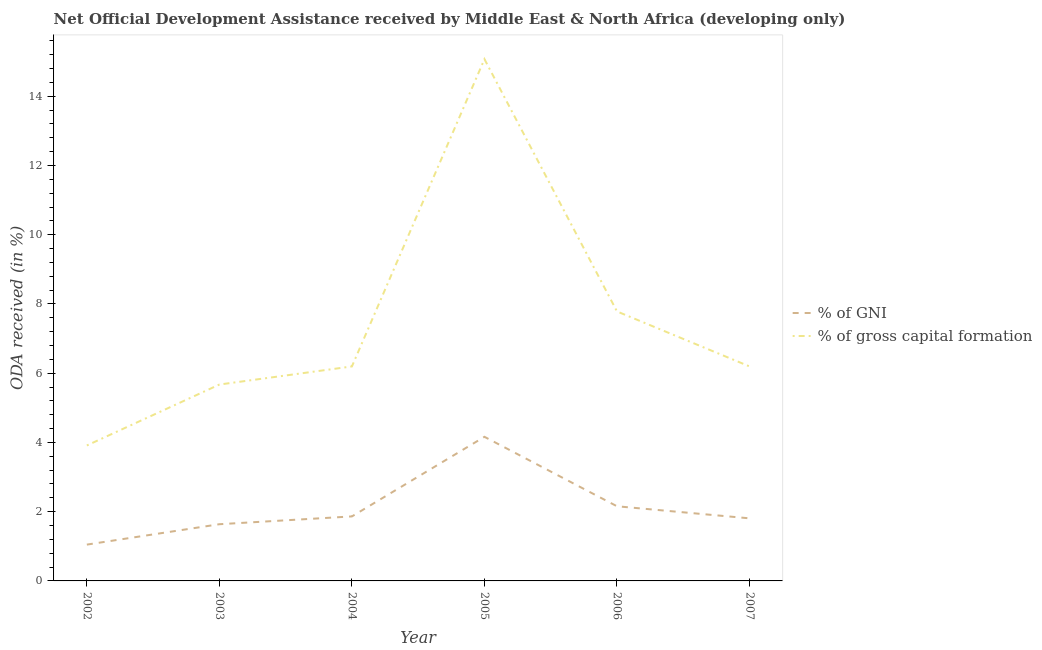Does the line corresponding to oda received as percentage of gni intersect with the line corresponding to oda received as percentage of gross capital formation?
Make the answer very short. No. What is the oda received as percentage of gross capital formation in 2005?
Provide a short and direct response. 15.07. Across all years, what is the maximum oda received as percentage of gni?
Ensure brevity in your answer.  4.16. Across all years, what is the minimum oda received as percentage of gni?
Offer a very short reply. 1.05. In which year was the oda received as percentage of gross capital formation maximum?
Your response must be concise. 2005. In which year was the oda received as percentage of gni minimum?
Your answer should be compact. 2002. What is the total oda received as percentage of gross capital formation in the graph?
Keep it short and to the point. 44.83. What is the difference between the oda received as percentage of gni in 2002 and that in 2003?
Your response must be concise. -0.59. What is the difference between the oda received as percentage of gni in 2006 and the oda received as percentage of gross capital formation in 2007?
Offer a very short reply. -4.04. What is the average oda received as percentage of gni per year?
Provide a short and direct response. 2.11. In the year 2005, what is the difference between the oda received as percentage of gni and oda received as percentage of gross capital formation?
Your response must be concise. -10.91. What is the ratio of the oda received as percentage of gni in 2002 to that in 2005?
Provide a succinct answer. 0.25. Is the oda received as percentage of gross capital formation in 2004 less than that in 2005?
Ensure brevity in your answer.  Yes. Is the difference between the oda received as percentage of gross capital formation in 2002 and 2003 greater than the difference between the oda received as percentage of gni in 2002 and 2003?
Make the answer very short. No. What is the difference between the highest and the second highest oda received as percentage of gross capital formation?
Your response must be concise. 7.29. What is the difference between the highest and the lowest oda received as percentage of gross capital formation?
Give a very brief answer. 11.16. Is the oda received as percentage of gross capital formation strictly greater than the oda received as percentage of gni over the years?
Provide a succinct answer. Yes. How many lines are there?
Provide a succinct answer. 2. How many years are there in the graph?
Give a very brief answer. 6. What is the difference between two consecutive major ticks on the Y-axis?
Your answer should be very brief. 2. Does the graph contain any zero values?
Keep it short and to the point. No. Where does the legend appear in the graph?
Offer a very short reply. Center right. How many legend labels are there?
Make the answer very short. 2. How are the legend labels stacked?
Provide a succinct answer. Vertical. What is the title of the graph?
Keep it short and to the point. Net Official Development Assistance received by Middle East & North Africa (developing only). Does "current US$" appear as one of the legend labels in the graph?
Give a very brief answer. No. What is the label or title of the Y-axis?
Provide a succinct answer. ODA received (in %). What is the ODA received (in %) of % of GNI in 2002?
Offer a very short reply. 1.05. What is the ODA received (in %) in % of gross capital formation in 2002?
Your answer should be very brief. 3.91. What is the ODA received (in %) in % of GNI in 2003?
Offer a very short reply. 1.64. What is the ODA received (in %) of % of gross capital formation in 2003?
Keep it short and to the point. 5.67. What is the ODA received (in %) in % of GNI in 2004?
Provide a succinct answer. 1.86. What is the ODA received (in %) in % of gross capital formation in 2004?
Provide a short and direct response. 6.2. What is the ODA received (in %) of % of GNI in 2005?
Ensure brevity in your answer.  4.16. What is the ODA received (in %) of % of gross capital formation in 2005?
Your answer should be very brief. 15.07. What is the ODA received (in %) in % of GNI in 2006?
Give a very brief answer. 2.16. What is the ODA received (in %) of % of gross capital formation in 2006?
Your response must be concise. 7.78. What is the ODA received (in %) of % of GNI in 2007?
Provide a short and direct response. 1.81. What is the ODA received (in %) of % of gross capital formation in 2007?
Give a very brief answer. 6.2. Across all years, what is the maximum ODA received (in %) of % of GNI?
Offer a very short reply. 4.16. Across all years, what is the maximum ODA received (in %) of % of gross capital formation?
Your answer should be very brief. 15.07. Across all years, what is the minimum ODA received (in %) of % of GNI?
Provide a succinct answer. 1.05. Across all years, what is the minimum ODA received (in %) in % of gross capital formation?
Provide a succinct answer. 3.91. What is the total ODA received (in %) in % of GNI in the graph?
Provide a short and direct response. 12.68. What is the total ODA received (in %) in % of gross capital formation in the graph?
Offer a terse response. 44.83. What is the difference between the ODA received (in %) in % of GNI in 2002 and that in 2003?
Make the answer very short. -0.59. What is the difference between the ODA received (in %) of % of gross capital formation in 2002 and that in 2003?
Provide a succinct answer. -1.76. What is the difference between the ODA received (in %) in % of GNI in 2002 and that in 2004?
Keep it short and to the point. -0.81. What is the difference between the ODA received (in %) in % of gross capital formation in 2002 and that in 2004?
Make the answer very short. -2.28. What is the difference between the ODA received (in %) of % of GNI in 2002 and that in 2005?
Your answer should be very brief. -3.11. What is the difference between the ODA received (in %) of % of gross capital formation in 2002 and that in 2005?
Make the answer very short. -11.16. What is the difference between the ODA received (in %) in % of GNI in 2002 and that in 2006?
Provide a short and direct response. -1.11. What is the difference between the ODA received (in %) in % of gross capital formation in 2002 and that in 2006?
Provide a short and direct response. -3.87. What is the difference between the ODA received (in %) of % of GNI in 2002 and that in 2007?
Your answer should be very brief. -0.76. What is the difference between the ODA received (in %) in % of gross capital formation in 2002 and that in 2007?
Provide a succinct answer. -2.28. What is the difference between the ODA received (in %) in % of GNI in 2003 and that in 2004?
Provide a short and direct response. -0.23. What is the difference between the ODA received (in %) in % of gross capital formation in 2003 and that in 2004?
Give a very brief answer. -0.52. What is the difference between the ODA received (in %) in % of GNI in 2003 and that in 2005?
Give a very brief answer. -2.52. What is the difference between the ODA received (in %) of % of gross capital formation in 2003 and that in 2005?
Offer a very short reply. -9.4. What is the difference between the ODA received (in %) in % of GNI in 2003 and that in 2006?
Provide a short and direct response. -0.52. What is the difference between the ODA received (in %) of % of gross capital formation in 2003 and that in 2006?
Your answer should be very brief. -2.11. What is the difference between the ODA received (in %) of % of GNI in 2003 and that in 2007?
Offer a terse response. -0.17. What is the difference between the ODA received (in %) in % of gross capital formation in 2003 and that in 2007?
Your answer should be very brief. -0.52. What is the difference between the ODA received (in %) of % of GNI in 2004 and that in 2005?
Your answer should be very brief. -2.3. What is the difference between the ODA received (in %) in % of gross capital formation in 2004 and that in 2005?
Your answer should be compact. -8.88. What is the difference between the ODA received (in %) of % of GNI in 2004 and that in 2006?
Make the answer very short. -0.29. What is the difference between the ODA received (in %) of % of gross capital formation in 2004 and that in 2006?
Offer a very short reply. -1.59. What is the difference between the ODA received (in %) in % of GNI in 2004 and that in 2007?
Your answer should be compact. 0.06. What is the difference between the ODA received (in %) of % of gross capital formation in 2004 and that in 2007?
Your response must be concise. -0. What is the difference between the ODA received (in %) in % of GNI in 2005 and that in 2006?
Provide a short and direct response. 2.01. What is the difference between the ODA received (in %) of % of gross capital formation in 2005 and that in 2006?
Keep it short and to the point. 7.29. What is the difference between the ODA received (in %) in % of GNI in 2005 and that in 2007?
Offer a very short reply. 2.35. What is the difference between the ODA received (in %) of % of gross capital formation in 2005 and that in 2007?
Your response must be concise. 8.88. What is the difference between the ODA received (in %) in % of GNI in 2006 and that in 2007?
Your response must be concise. 0.35. What is the difference between the ODA received (in %) in % of gross capital formation in 2006 and that in 2007?
Ensure brevity in your answer.  1.59. What is the difference between the ODA received (in %) of % of GNI in 2002 and the ODA received (in %) of % of gross capital formation in 2003?
Provide a short and direct response. -4.62. What is the difference between the ODA received (in %) in % of GNI in 2002 and the ODA received (in %) in % of gross capital formation in 2004?
Keep it short and to the point. -5.15. What is the difference between the ODA received (in %) of % of GNI in 2002 and the ODA received (in %) of % of gross capital formation in 2005?
Provide a succinct answer. -14.02. What is the difference between the ODA received (in %) of % of GNI in 2002 and the ODA received (in %) of % of gross capital formation in 2006?
Keep it short and to the point. -6.74. What is the difference between the ODA received (in %) of % of GNI in 2002 and the ODA received (in %) of % of gross capital formation in 2007?
Keep it short and to the point. -5.15. What is the difference between the ODA received (in %) of % of GNI in 2003 and the ODA received (in %) of % of gross capital formation in 2004?
Offer a terse response. -4.56. What is the difference between the ODA received (in %) in % of GNI in 2003 and the ODA received (in %) in % of gross capital formation in 2005?
Make the answer very short. -13.43. What is the difference between the ODA received (in %) in % of GNI in 2003 and the ODA received (in %) in % of gross capital formation in 2006?
Keep it short and to the point. -6.15. What is the difference between the ODA received (in %) in % of GNI in 2003 and the ODA received (in %) in % of gross capital formation in 2007?
Your answer should be very brief. -4.56. What is the difference between the ODA received (in %) of % of GNI in 2004 and the ODA received (in %) of % of gross capital formation in 2005?
Your answer should be very brief. -13.21. What is the difference between the ODA received (in %) of % of GNI in 2004 and the ODA received (in %) of % of gross capital formation in 2006?
Offer a very short reply. -5.92. What is the difference between the ODA received (in %) of % of GNI in 2004 and the ODA received (in %) of % of gross capital formation in 2007?
Your response must be concise. -4.33. What is the difference between the ODA received (in %) of % of GNI in 2005 and the ODA received (in %) of % of gross capital formation in 2006?
Ensure brevity in your answer.  -3.62. What is the difference between the ODA received (in %) in % of GNI in 2005 and the ODA received (in %) in % of gross capital formation in 2007?
Keep it short and to the point. -2.03. What is the difference between the ODA received (in %) of % of GNI in 2006 and the ODA received (in %) of % of gross capital formation in 2007?
Make the answer very short. -4.04. What is the average ODA received (in %) in % of GNI per year?
Offer a terse response. 2.11. What is the average ODA received (in %) of % of gross capital formation per year?
Provide a short and direct response. 7.47. In the year 2002, what is the difference between the ODA received (in %) of % of GNI and ODA received (in %) of % of gross capital formation?
Your answer should be compact. -2.86. In the year 2003, what is the difference between the ODA received (in %) in % of GNI and ODA received (in %) in % of gross capital formation?
Provide a short and direct response. -4.03. In the year 2004, what is the difference between the ODA received (in %) of % of GNI and ODA received (in %) of % of gross capital formation?
Ensure brevity in your answer.  -4.33. In the year 2005, what is the difference between the ODA received (in %) in % of GNI and ODA received (in %) in % of gross capital formation?
Provide a succinct answer. -10.91. In the year 2006, what is the difference between the ODA received (in %) in % of GNI and ODA received (in %) in % of gross capital formation?
Provide a succinct answer. -5.63. In the year 2007, what is the difference between the ODA received (in %) in % of GNI and ODA received (in %) in % of gross capital formation?
Your answer should be compact. -4.39. What is the ratio of the ODA received (in %) of % of GNI in 2002 to that in 2003?
Your answer should be very brief. 0.64. What is the ratio of the ODA received (in %) of % of gross capital formation in 2002 to that in 2003?
Offer a very short reply. 0.69. What is the ratio of the ODA received (in %) of % of GNI in 2002 to that in 2004?
Your response must be concise. 0.56. What is the ratio of the ODA received (in %) of % of gross capital formation in 2002 to that in 2004?
Keep it short and to the point. 0.63. What is the ratio of the ODA received (in %) in % of GNI in 2002 to that in 2005?
Give a very brief answer. 0.25. What is the ratio of the ODA received (in %) of % of gross capital formation in 2002 to that in 2005?
Provide a succinct answer. 0.26. What is the ratio of the ODA received (in %) of % of GNI in 2002 to that in 2006?
Ensure brevity in your answer.  0.49. What is the ratio of the ODA received (in %) of % of gross capital formation in 2002 to that in 2006?
Ensure brevity in your answer.  0.5. What is the ratio of the ODA received (in %) of % of GNI in 2002 to that in 2007?
Offer a very short reply. 0.58. What is the ratio of the ODA received (in %) in % of gross capital formation in 2002 to that in 2007?
Keep it short and to the point. 0.63. What is the ratio of the ODA received (in %) in % of GNI in 2003 to that in 2004?
Ensure brevity in your answer.  0.88. What is the ratio of the ODA received (in %) of % of gross capital formation in 2003 to that in 2004?
Make the answer very short. 0.92. What is the ratio of the ODA received (in %) of % of GNI in 2003 to that in 2005?
Give a very brief answer. 0.39. What is the ratio of the ODA received (in %) in % of gross capital formation in 2003 to that in 2005?
Your response must be concise. 0.38. What is the ratio of the ODA received (in %) in % of GNI in 2003 to that in 2006?
Offer a very short reply. 0.76. What is the ratio of the ODA received (in %) in % of gross capital formation in 2003 to that in 2006?
Give a very brief answer. 0.73. What is the ratio of the ODA received (in %) of % of GNI in 2003 to that in 2007?
Your answer should be very brief. 0.91. What is the ratio of the ODA received (in %) of % of gross capital formation in 2003 to that in 2007?
Provide a succinct answer. 0.92. What is the ratio of the ODA received (in %) of % of GNI in 2004 to that in 2005?
Your answer should be compact. 0.45. What is the ratio of the ODA received (in %) of % of gross capital formation in 2004 to that in 2005?
Provide a short and direct response. 0.41. What is the ratio of the ODA received (in %) of % of GNI in 2004 to that in 2006?
Offer a terse response. 0.86. What is the ratio of the ODA received (in %) in % of gross capital formation in 2004 to that in 2006?
Your answer should be very brief. 0.8. What is the ratio of the ODA received (in %) of % of GNI in 2004 to that in 2007?
Make the answer very short. 1.03. What is the ratio of the ODA received (in %) of % of GNI in 2005 to that in 2006?
Offer a terse response. 1.93. What is the ratio of the ODA received (in %) of % of gross capital formation in 2005 to that in 2006?
Keep it short and to the point. 1.94. What is the ratio of the ODA received (in %) of % of GNI in 2005 to that in 2007?
Offer a terse response. 2.3. What is the ratio of the ODA received (in %) of % of gross capital formation in 2005 to that in 2007?
Your answer should be compact. 2.43. What is the ratio of the ODA received (in %) of % of GNI in 2006 to that in 2007?
Provide a short and direct response. 1.19. What is the ratio of the ODA received (in %) in % of gross capital formation in 2006 to that in 2007?
Provide a succinct answer. 1.26. What is the difference between the highest and the second highest ODA received (in %) in % of GNI?
Ensure brevity in your answer.  2.01. What is the difference between the highest and the second highest ODA received (in %) of % of gross capital formation?
Your answer should be compact. 7.29. What is the difference between the highest and the lowest ODA received (in %) of % of GNI?
Provide a short and direct response. 3.11. What is the difference between the highest and the lowest ODA received (in %) of % of gross capital formation?
Provide a succinct answer. 11.16. 